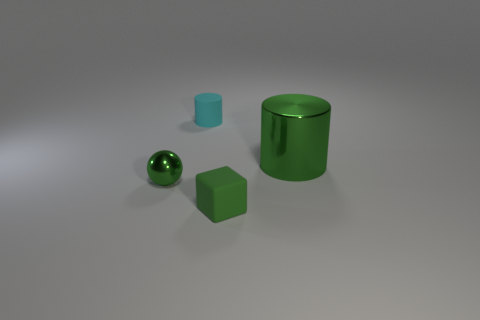The block that is the same color as the large shiny cylinder is what size?
Ensure brevity in your answer.  Small. What number of green things are left of the small cyan matte cylinder and on the right side of the block?
Ensure brevity in your answer.  0. What is the tiny green object that is to the left of the tiny rubber cylinder made of?
Your answer should be compact. Metal. How many cubes are the same color as the big shiny thing?
Give a very brief answer. 1. There is another object that is the same material as the cyan thing; what is its size?
Your answer should be compact. Small. What number of objects are cyan rubber cylinders or green metallic objects?
Your response must be concise. 3. The small thing that is to the right of the small cyan matte cylinder is what color?
Keep it short and to the point. Green. There is another rubber thing that is the same shape as the large green object; what is its size?
Give a very brief answer. Small. How many objects are either objects left of the big green object or green things that are to the right of the tiny metallic thing?
Offer a terse response. 4. There is a object that is to the left of the matte block and to the right of the small green shiny thing; how big is it?
Keep it short and to the point. Small. 